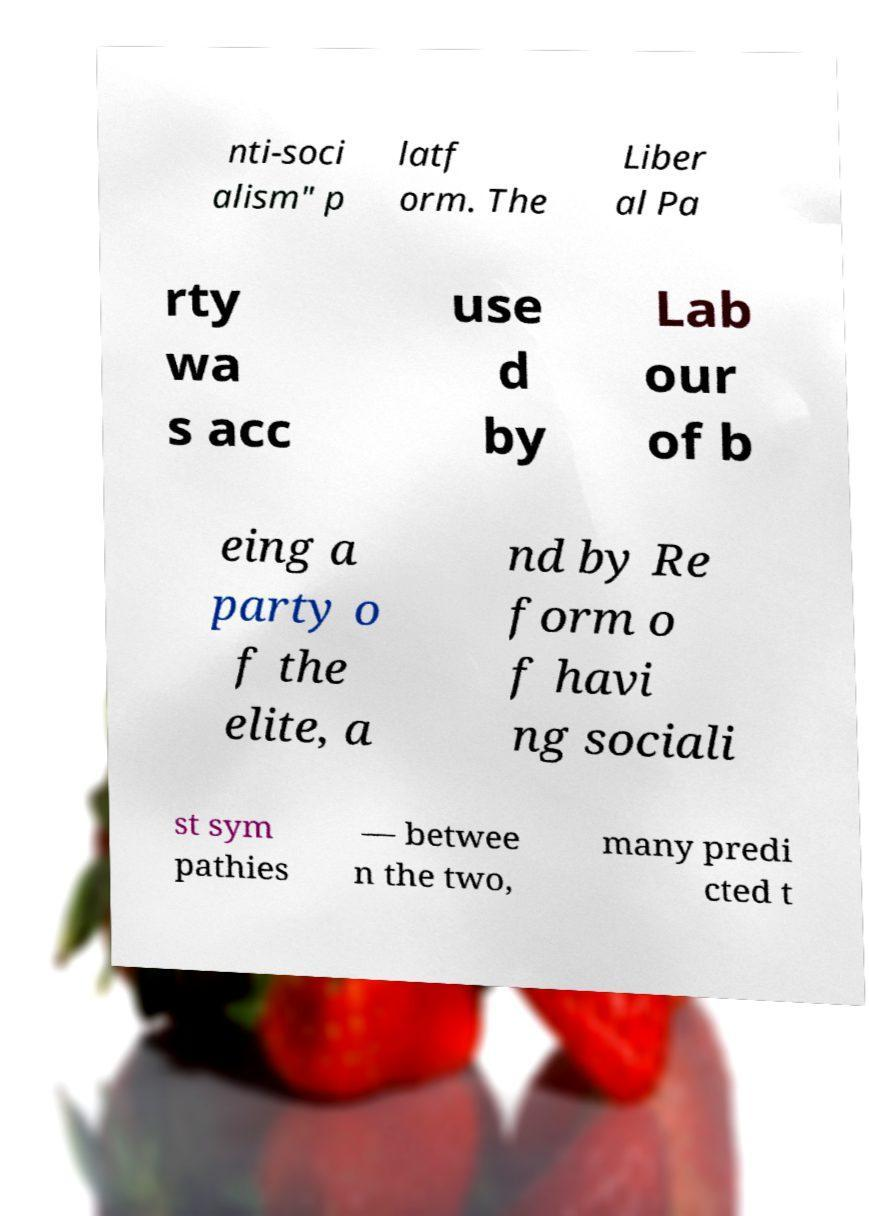What messages or text are displayed in this image? I need them in a readable, typed format. nti-soci alism" p latf orm. The Liber al Pa rty wa s acc use d by Lab our of b eing a party o f the elite, a nd by Re form o f havi ng sociali st sym pathies — betwee n the two, many predi cted t 